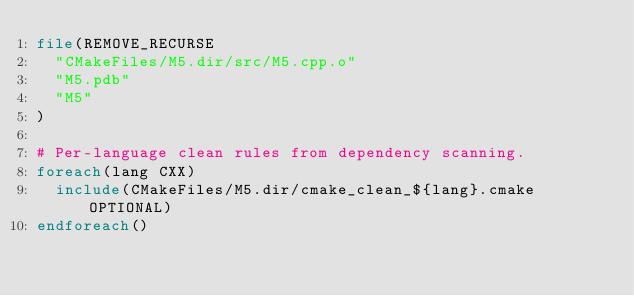<code> <loc_0><loc_0><loc_500><loc_500><_CMake_>file(REMOVE_RECURSE
  "CMakeFiles/M5.dir/src/M5.cpp.o"
  "M5.pdb"
  "M5"
)

# Per-language clean rules from dependency scanning.
foreach(lang CXX)
  include(CMakeFiles/M5.dir/cmake_clean_${lang}.cmake OPTIONAL)
endforeach()
</code> 